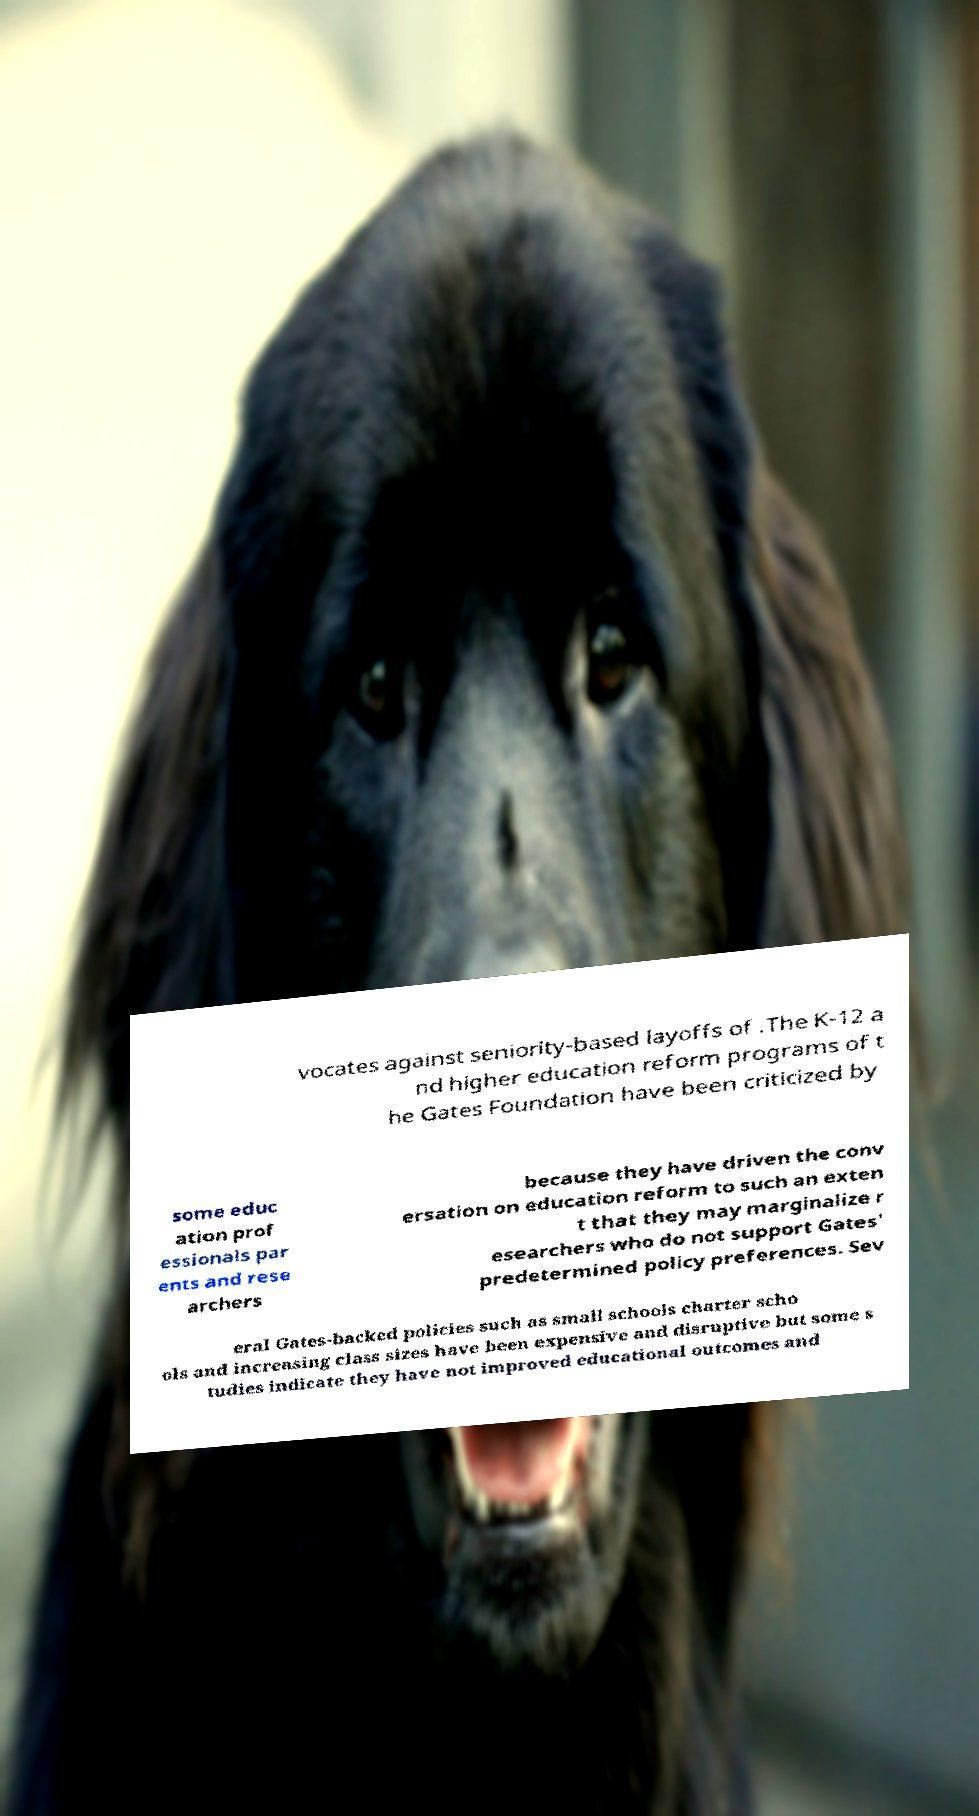Please read and relay the text visible in this image. What does it say? vocates against seniority-based layoffs of .The K-12 a nd higher education reform programs of t he Gates Foundation have been criticized by some educ ation prof essionals par ents and rese archers because they have driven the conv ersation on education reform to such an exten t that they may marginalize r esearchers who do not support Gates' predetermined policy preferences. Sev eral Gates-backed policies such as small schools charter scho ols and increasing class sizes have been expensive and disruptive but some s tudies indicate they have not improved educational outcomes and 